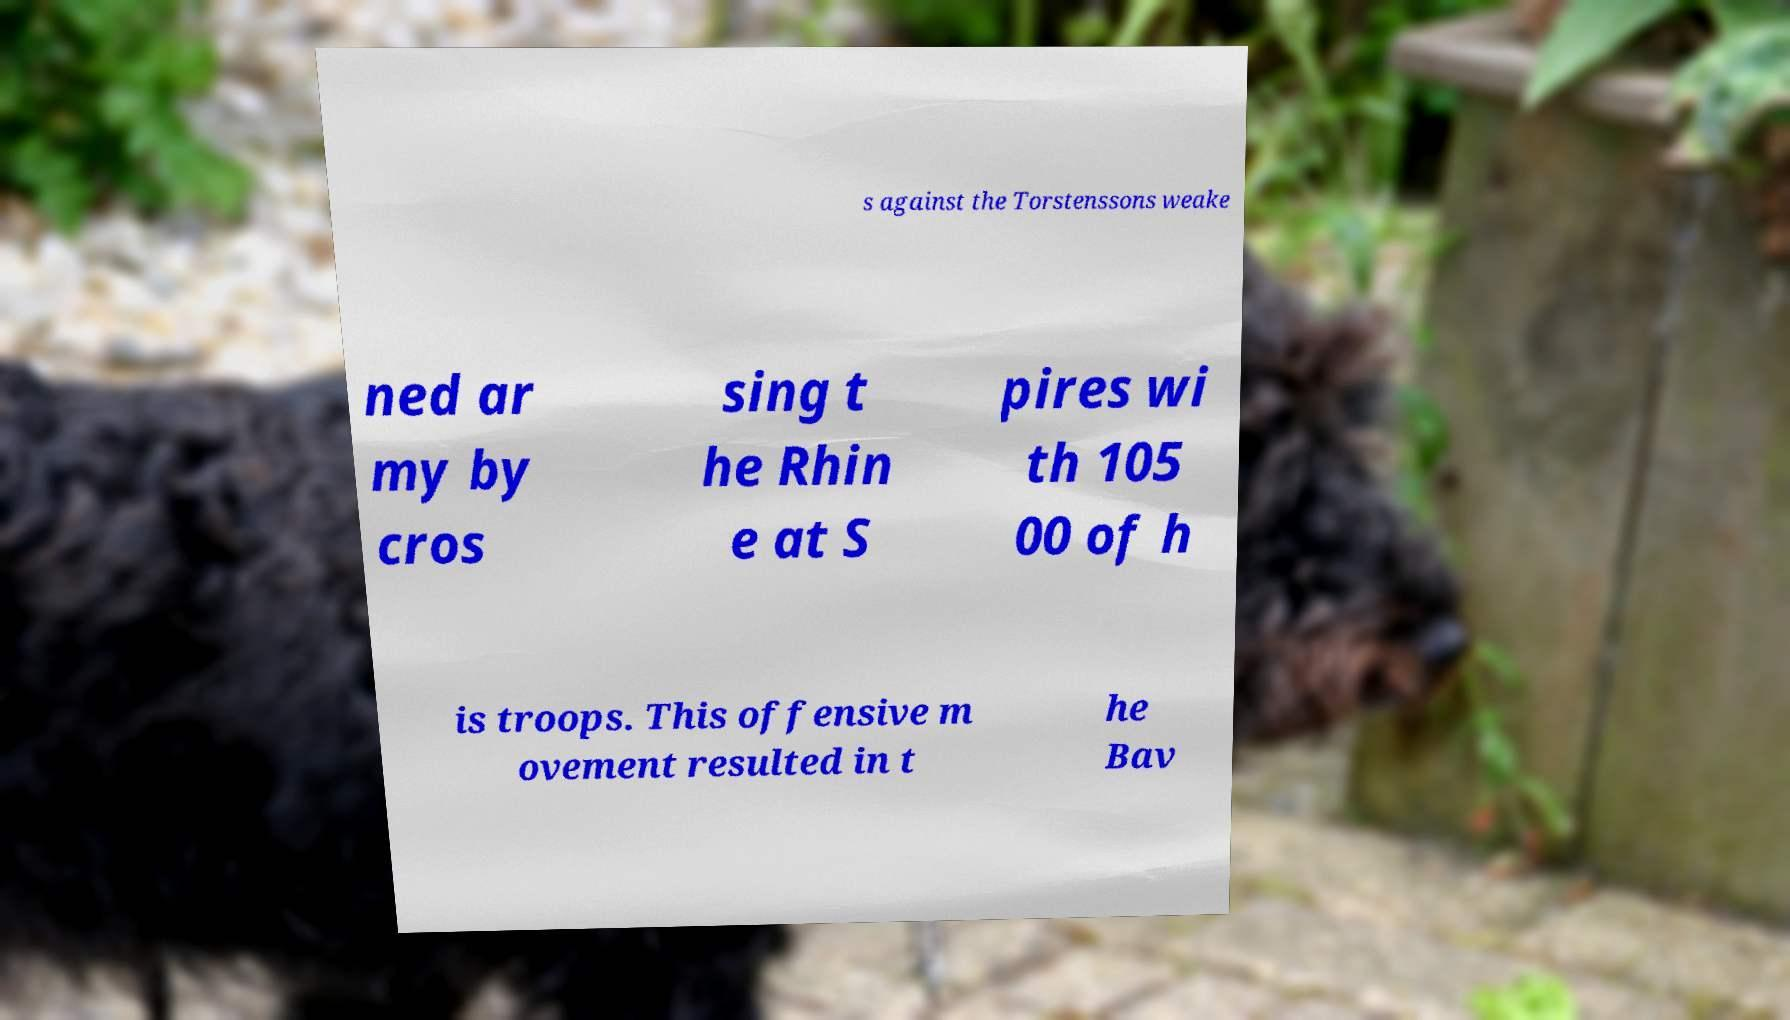Can you read and provide the text displayed in the image?This photo seems to have some interesting text. Can you extract and type it out for me? s against the Torstenssons weake ned ar my by cros sing t he Rhin e at S pires wi th 105 00 of h is troops. This offensive m ovement resulted in t he Bav 